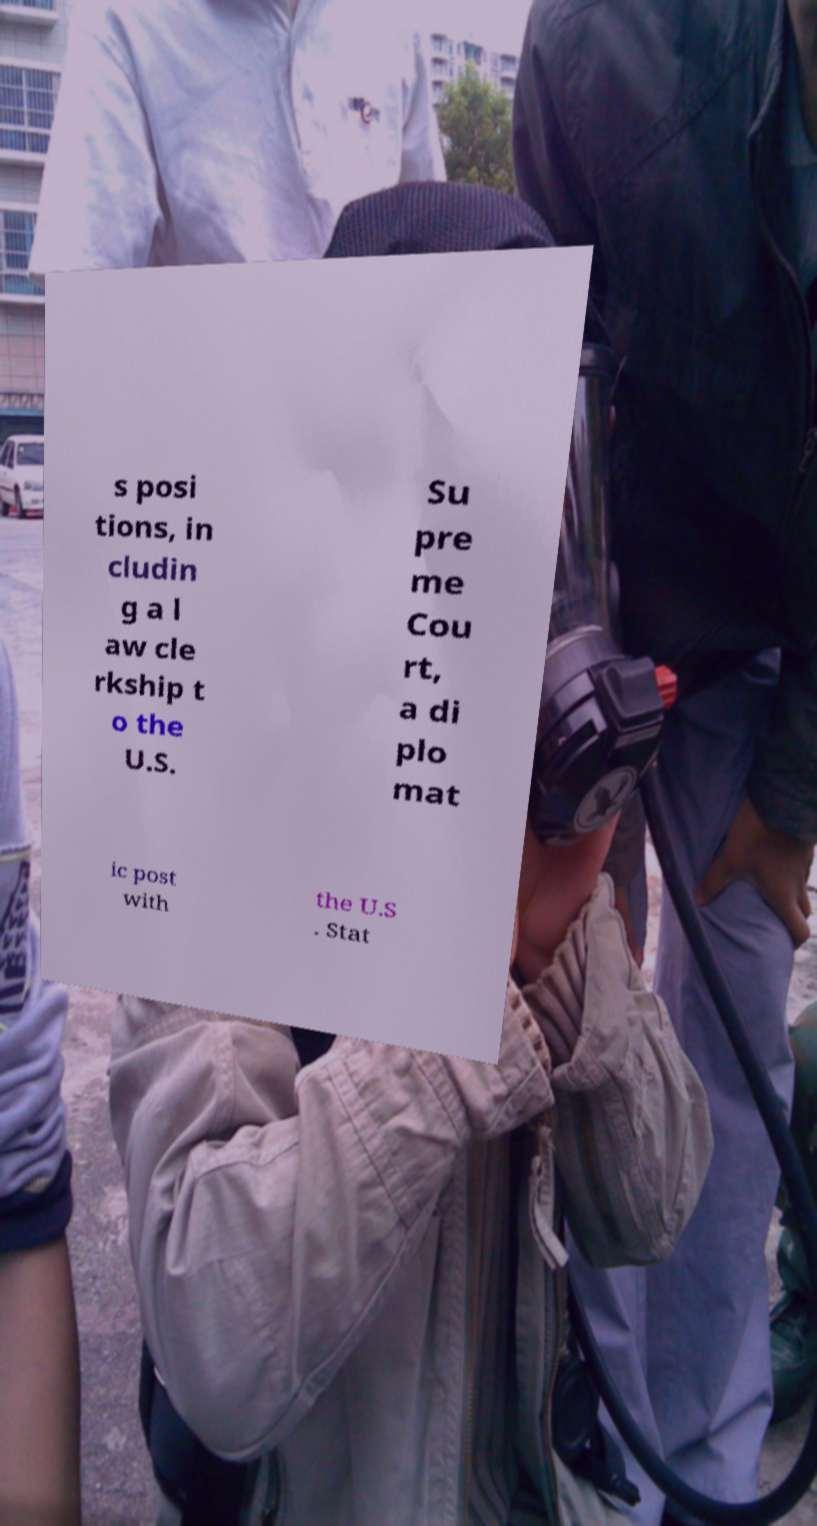I need the written content from this picture converted into text. Can you do that? s posi tions, in cludin g a l aw cle rkship t o the U.S. Su pre me Cou rt, a di plo mat ic post with the U.S . Stat 